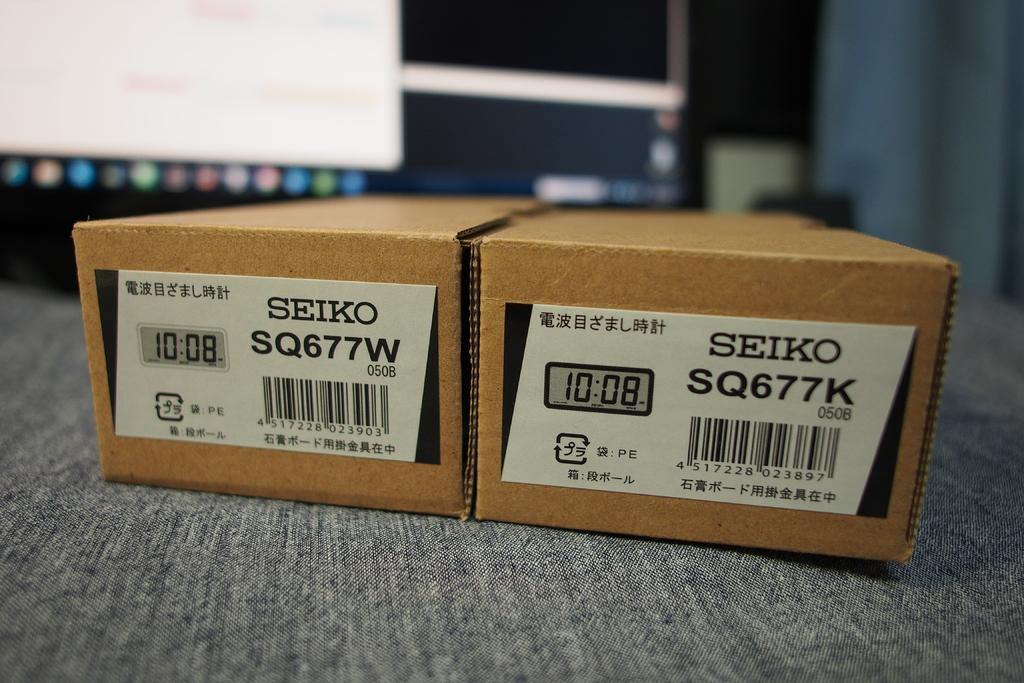<image>
Give a short and clear explanation of the subsequent image. Two Seiko cardboard boxes sit near a monitor. 